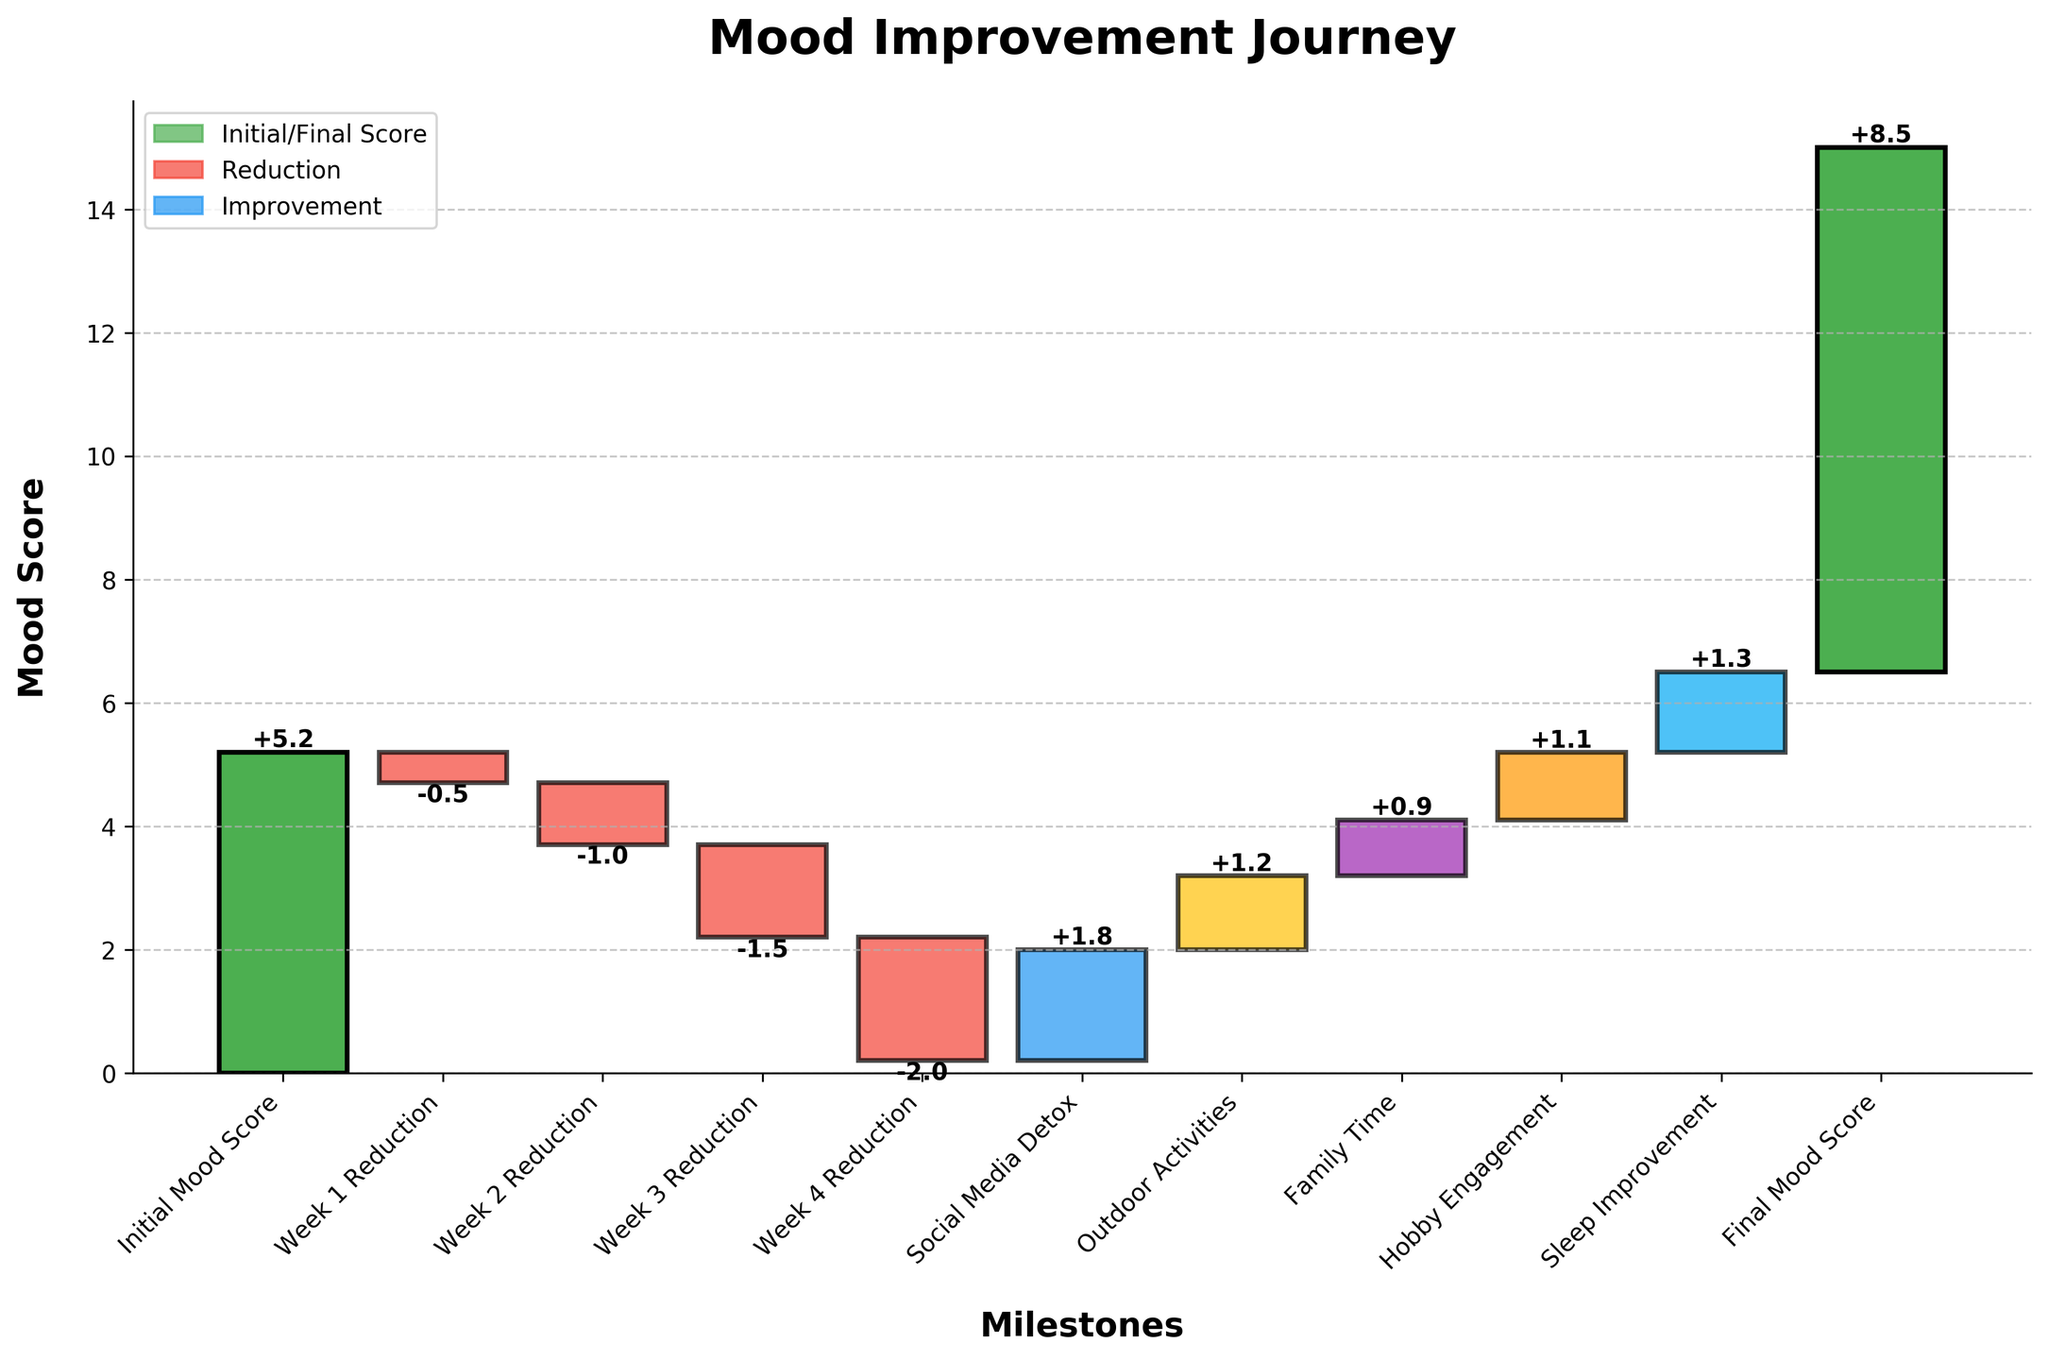What is the title of the chart? The title is located at the top of the chart and shows the main topic or purpose.
Answer: Mood Improvement Journey How many milestones are there in total? Count the number of data points or bars along the x-axis from the start to the end.
Answer: 11 Which milestone shows the largest reduction in mood score? Compare the values at each reduction milestone (negative values) and identify the largest one.
Answer: Week 4 Reduction What is the mood score at the end of Week 2 Reduction? Add the values cumulatively up to the end of Week 2 Reduction: 5.2 - 0.5 - 1.0 = 3.7
Answer: 3.7 How does the final mood score compare to the initial mood score? Subtract the initial mood score from the final mood score to see the change: 8.5 - 5.2 = 3.3
Answer: The final mood score is 3.3 higher What is the total improvement in mood score during the Social Media Detox, Outdoor Activities, Family Time, Hobby Engagement, and Sleep Improvement phases? Sum the improvements from these specific categories: 1.8 + 1.2 + 0.9 + 1.1 + 1.3 = 6.3
Answer: 6.3 Which single improvement category had the highest positive impact on mood score? Identify the highest positive value among the improvement categories: Social Media Detox (1.8)
Answer: Social Media Detox What is the net change in mood score after completing all reductions and improvements? Sum the cumulative values to get the net change: -5.0 + 6.3 = 1.3, then add this to the initial score: 5.2 + 1.3 = 6.5
Answer: 6.5 Between which two milestones is the improvement in mood score the largest? Compare the increases between all improvement milestones to identify the largest one. It is between Hobby Engagement (1.1) and Sleep Improvement (1.3).
Answer: Between Hobby Engagement and Sleep Improvement How does the reduction in Week 3 compare to the reduction in Week 1 and Week 2? Subtract the values of Week 1 and Week 2 from Week 3 to compare: -1.5 is greater reduction than -0.5 and -1.0
Answer: Week 3 has a greater reduction than Week 1 and Week 2 When does the mood score first start to improve? Look at the milestone categories and identify when the positive values start appearing after all reductions.
Answer: Social Media Detox 